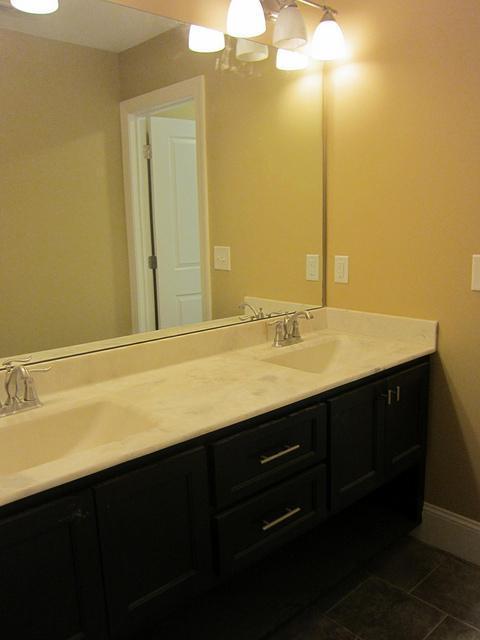How many sinks are shown?
Give a very brief answer. 2. How many sinks can you see?
Give a very brief answer. 2. How many people are wearing white pants?
Give a very brief answer. 0. 